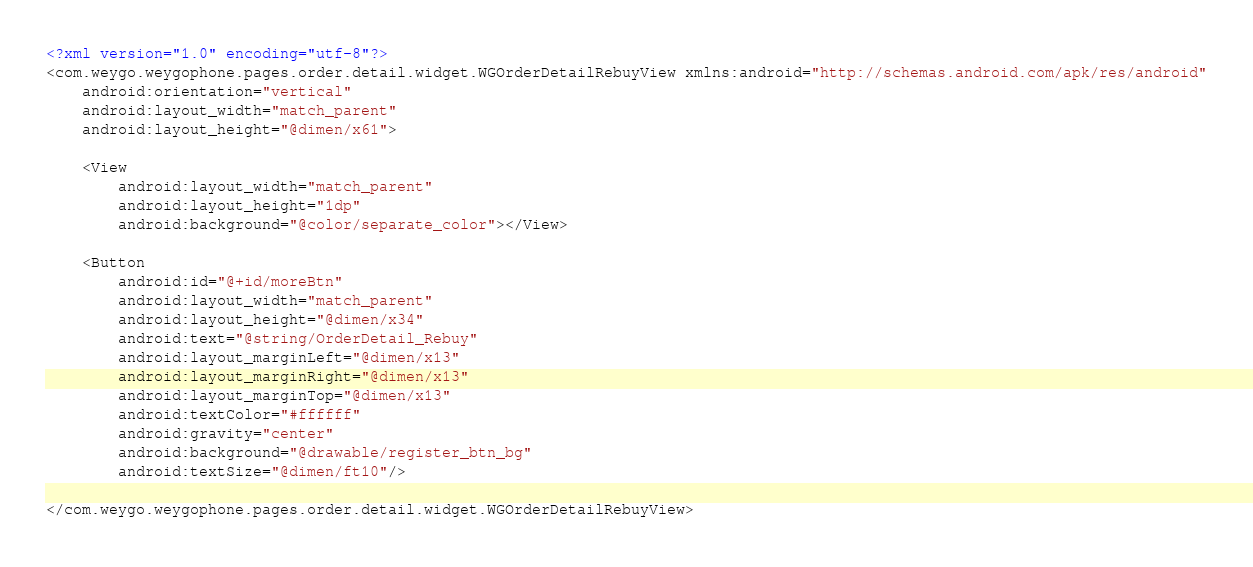Convert code to text. <code><loc_0><loc_0><loc_500><loc_500><_XML_><?xml version="1.0" encoding="utf-8"?>
<com.weygo.weygophone.pages.order.detail.widget.WGOrderDetailRebuyView xmlns:android="http://schemas.android.com/apk/res/android"
    android:orientation="vertical"
    android:layout_width="match_parent"
    android:layout_height="@dimen/x61">

    <View
        android:layout_width="match_parent"
        android:layout_height="1dp"
        android:background="@color/separate_color"></View>

    <Button
        android:id="@+id/moreBtn"
        android:layout_width="match_parent"
        android:layout_height="@dimen/x34"
        android:text="@string/OrderDetail_Rebuy"
        android:layout_marginLeft="@dimen/x13"
        android:layout_marginRight="@dimen/x13"
        android:layout_marginTop="@dimen/x13"
        android:textColor="#ffffff"
        android:gravity="center"
        android:background="@drawable/register_btn_bg"
        android:textSize="@dimen/ft10"/>

</com.weygo.weygophone.pages.order.detail.widget.WGOrderDetailRebuyView></code> 